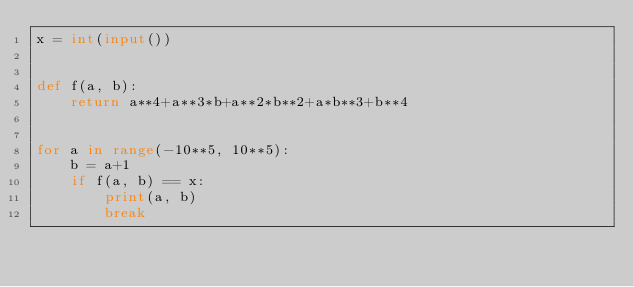<code> <loc_0><loc_0><loc_500><loc_500><_Python_>x = int(input())


def f(a, b):
    return a**4+a**3*b+a**2*b**2+a*b**3+b**4


for a in range(-10**5, 10**5):
    b = a+1
    if f(a, b) == x:
        print(a, b)
        break
</code> 